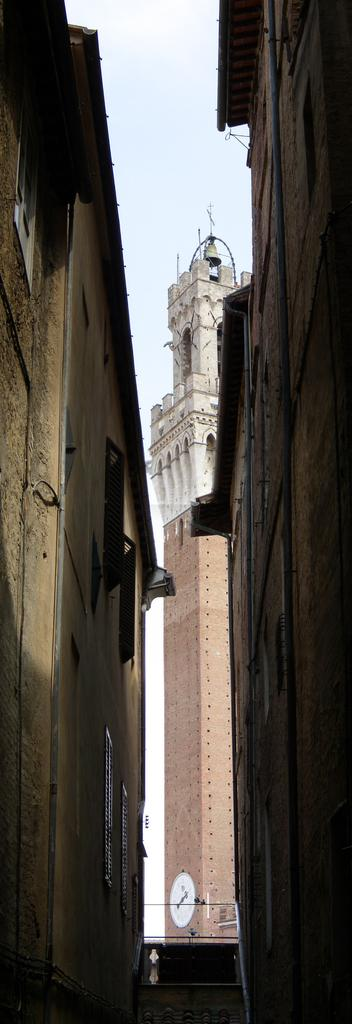What type of structures can be seen in the image? There are buildings in the image. What object in the image can be used to tell time? There is a clock in the image. How many flies can be seen on the clock in the image? There are no flies present in the image, and therefore no such activity can be observed. What type of screw is used to hold the clock together in the image? There is no visible screw in the image, as the focus is on the clock itself and not its internal components. 